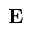Convert formula to latex. <formula><loc_0><loc_0><loc_500><loc_500>E</formula> 